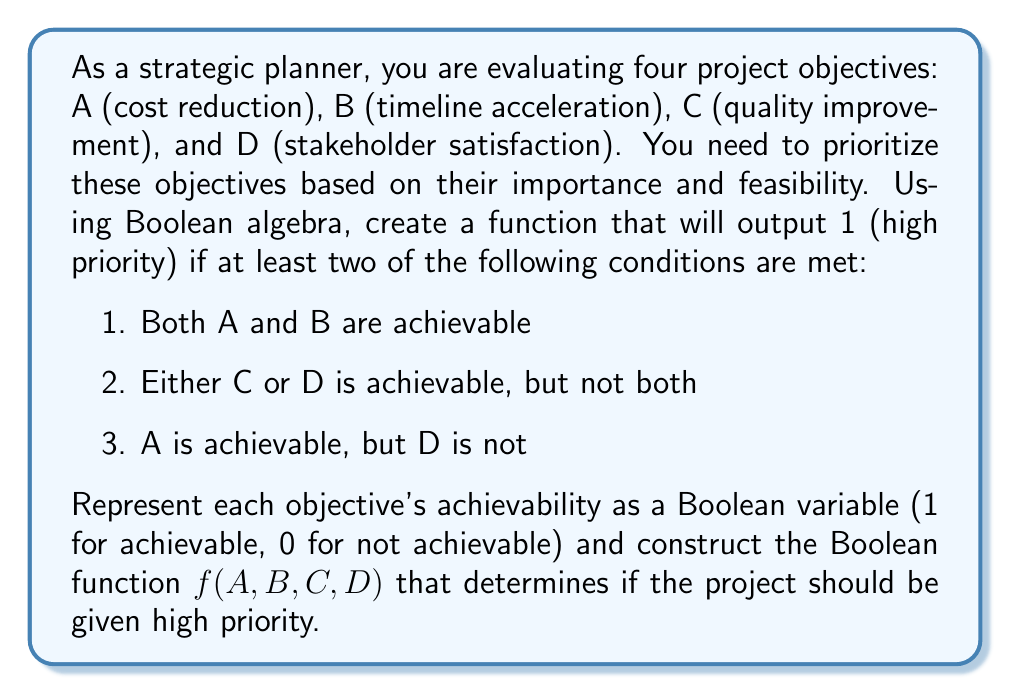Provide a solution to this math problem. Let's approach this step-by-step:

1. First, let's translate each condition into Boolean algebra:
   - Condition 1: $A \cdot B$
   - Condition 2: $C \oplus D$ (exclusive OR)
   - Condition 3: $A \cdot \overline{D}$

2. We need at least two of these conditions to be true. We can represent this using the following Boolean function:

   $f(A,B,C,D) = (A \cdot B + C \oplus D + A \cdot \overline{D})\geq 2$

3. To simplify this, we can use the "at least 2 out of 3" function, which is:

   $f(x,y,z) = xy + yz + xz$

   Where $x = A \cdot B$, $y = C \oplus D$, and $z = A \cdot \overline{D}$

4. Substituting these back:

   $f(A,B,C,D) = (A \cdot B)(C \oplus D) + (C \oplus D)(A \cdot \overline{D}) + (A \cdot B)(A \cdot \overline{D})$

5. Simplifying:
   - $(A \cdot B)(C \oplus D) = ABC \oplus ABD$
   - $(C \oplus D)(A \cdot \overline{D}) = AC\overline{D}$
   - $(A \cdot B)(A \cdot \overline{D}) = AB\overline{D}$

6. Combining terms:

   $f(A,B,C,D) = ABC \oplus ABD \oplus AC\overline{D} \oplus AB\overline{D}$

This Boolean function will output 1 (high priority) if at least two of the specified conditions are met, and 0 otherwise.
Answer: $f(A,B,C,D) = ABC \oplus ABD \oplus AC\overline{D} \oplus AB\overline{D}$ 